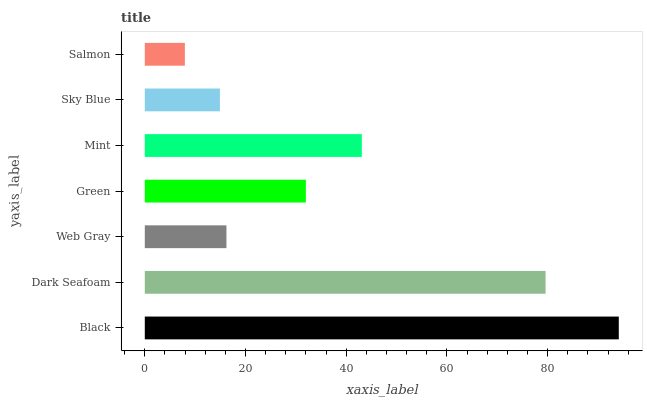Is Salmon the minimum?
Answer yes or no. Yes. Is Black the maximum?
Answer yes or no. Yes. Is Dark Seafoam the minimum?
Answer yes or no. No. Is Dark Seafoam the maximum?
Answer yes or no. No. Is Black greater than Dark Seafoam?
Answer yes or no. Yes. Is Dark Seafoam less than Black?
Answer yes or no. Yes. Is Dark Seafoam greater than Black?
Answer yes or no. No. Is Black less than Dark Seafoam?
Answer yes or no. No. Is Green the high median?
Answer yes or no. Yes. Is Green the low median?
Answer yes or no. Yes. Is Salmon the high median?
Answer yes or no. No. Is Salmon the low median?
Answer yes or no. No. 